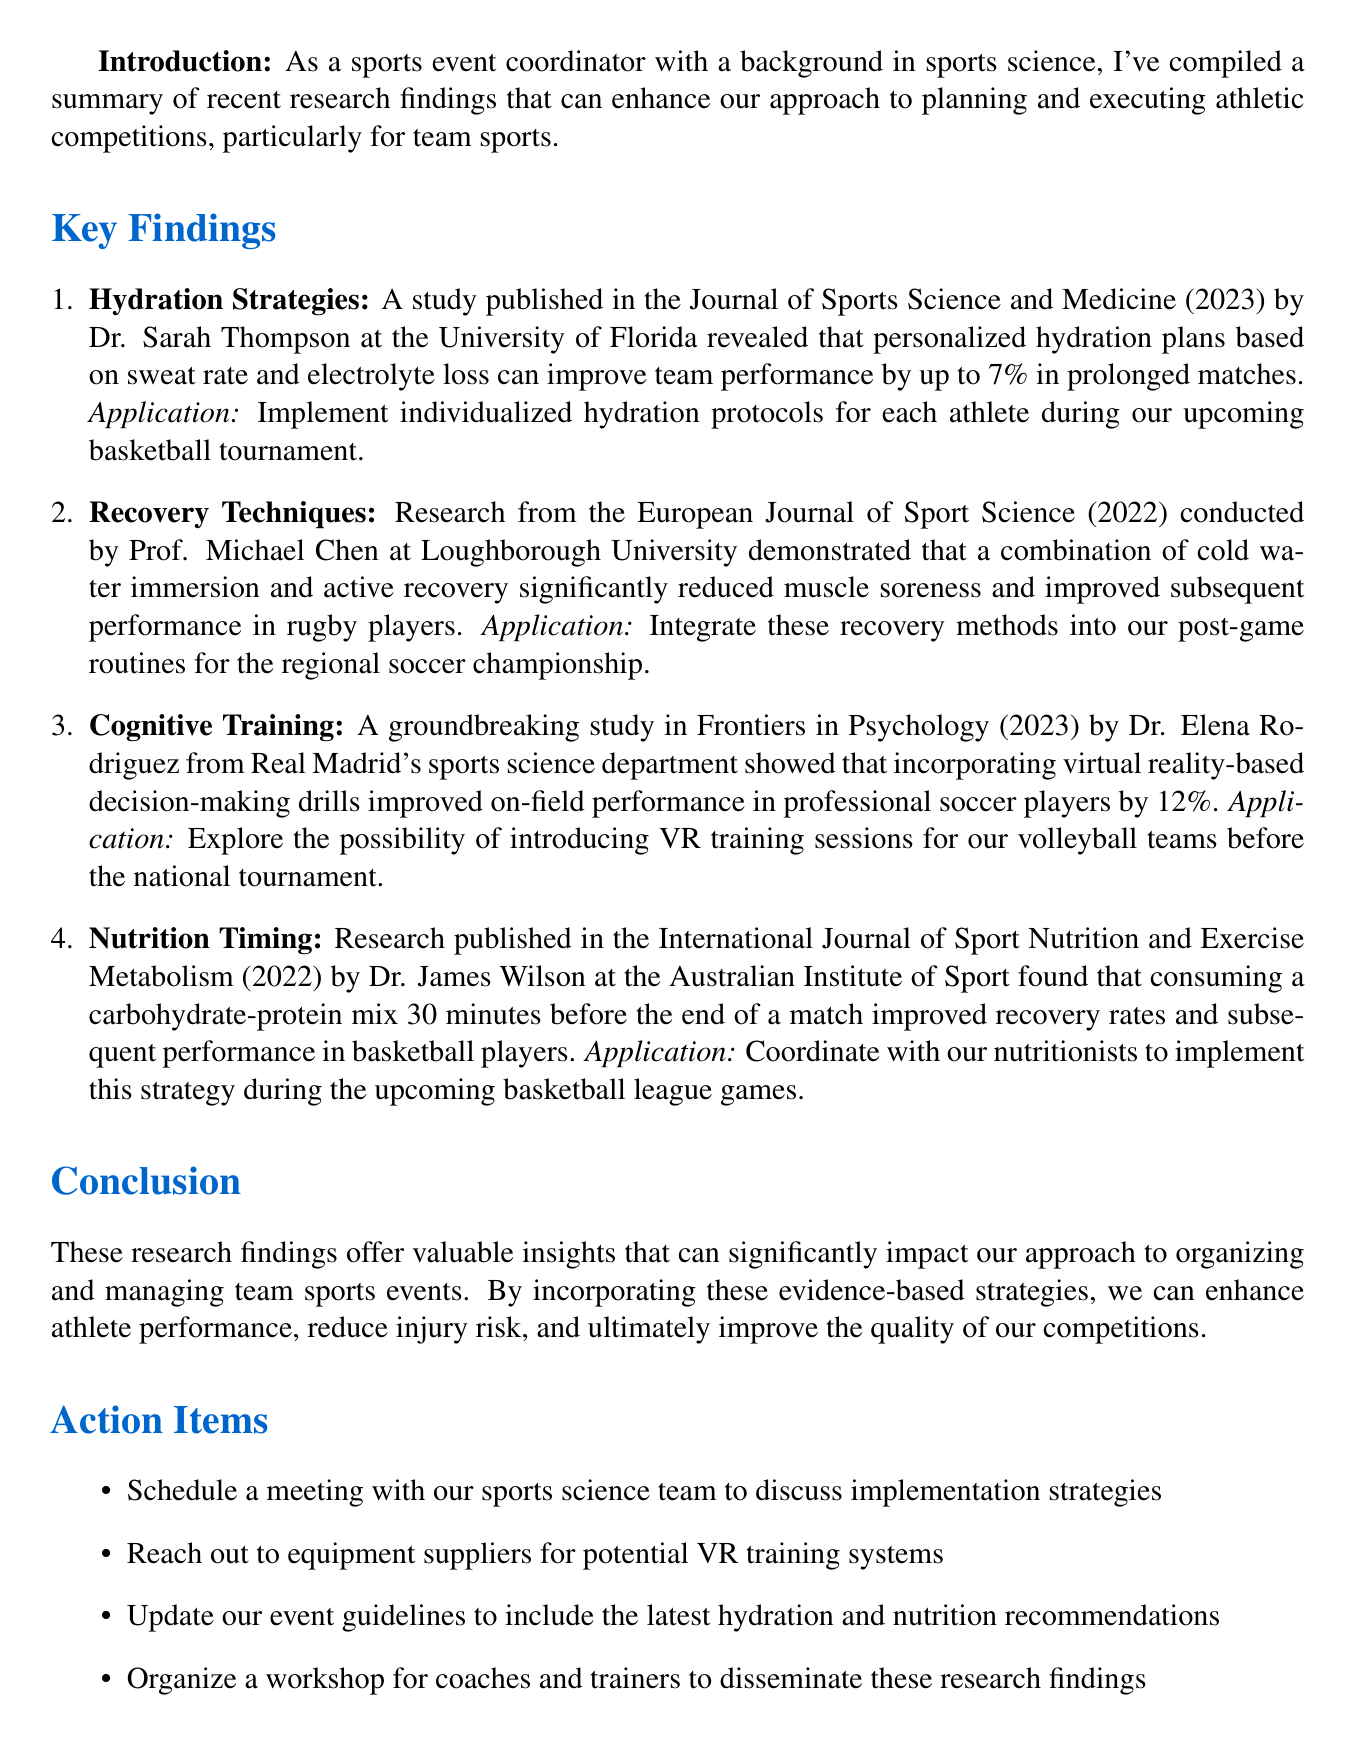what is the title of the memo? The title is mentioned at the beginning of the document, summarizing its primary focus.
Answer: Latest Sports Science Research Findings for Optimizing Team Sports Performance who conducted the hydration strategies research? The document provides details on various studies, including the authors and their affiliations.
Answer: Dr. Sarah Thompson how much can personalized hydration plans improve team performance? The document specifies the percentage improvement found in the relevant study.
Answer: 7% what year was the recovery techniques research published? The document states the publication year of the study that discusses recovery techniques.
Answer: 2022 which sport is mentioned in the cognitive training study? The document references a specific team sport related to the study of cognitive training.
Answer: Soccer what is one application of cold water immersion techniques? The document outlines practical applications of the research findings to athletic competitions.
Answer: Post-game routines for the regional soccer championship which journal published the nutrition timing research? The document references the journal name where this particular research was featured.
Answer: International Journal of Sport Nutrition and Exercise Metabolism how many action items are listed in the document? The section detailing action items specifies the total number of such items mentioned.
Answer: 4 